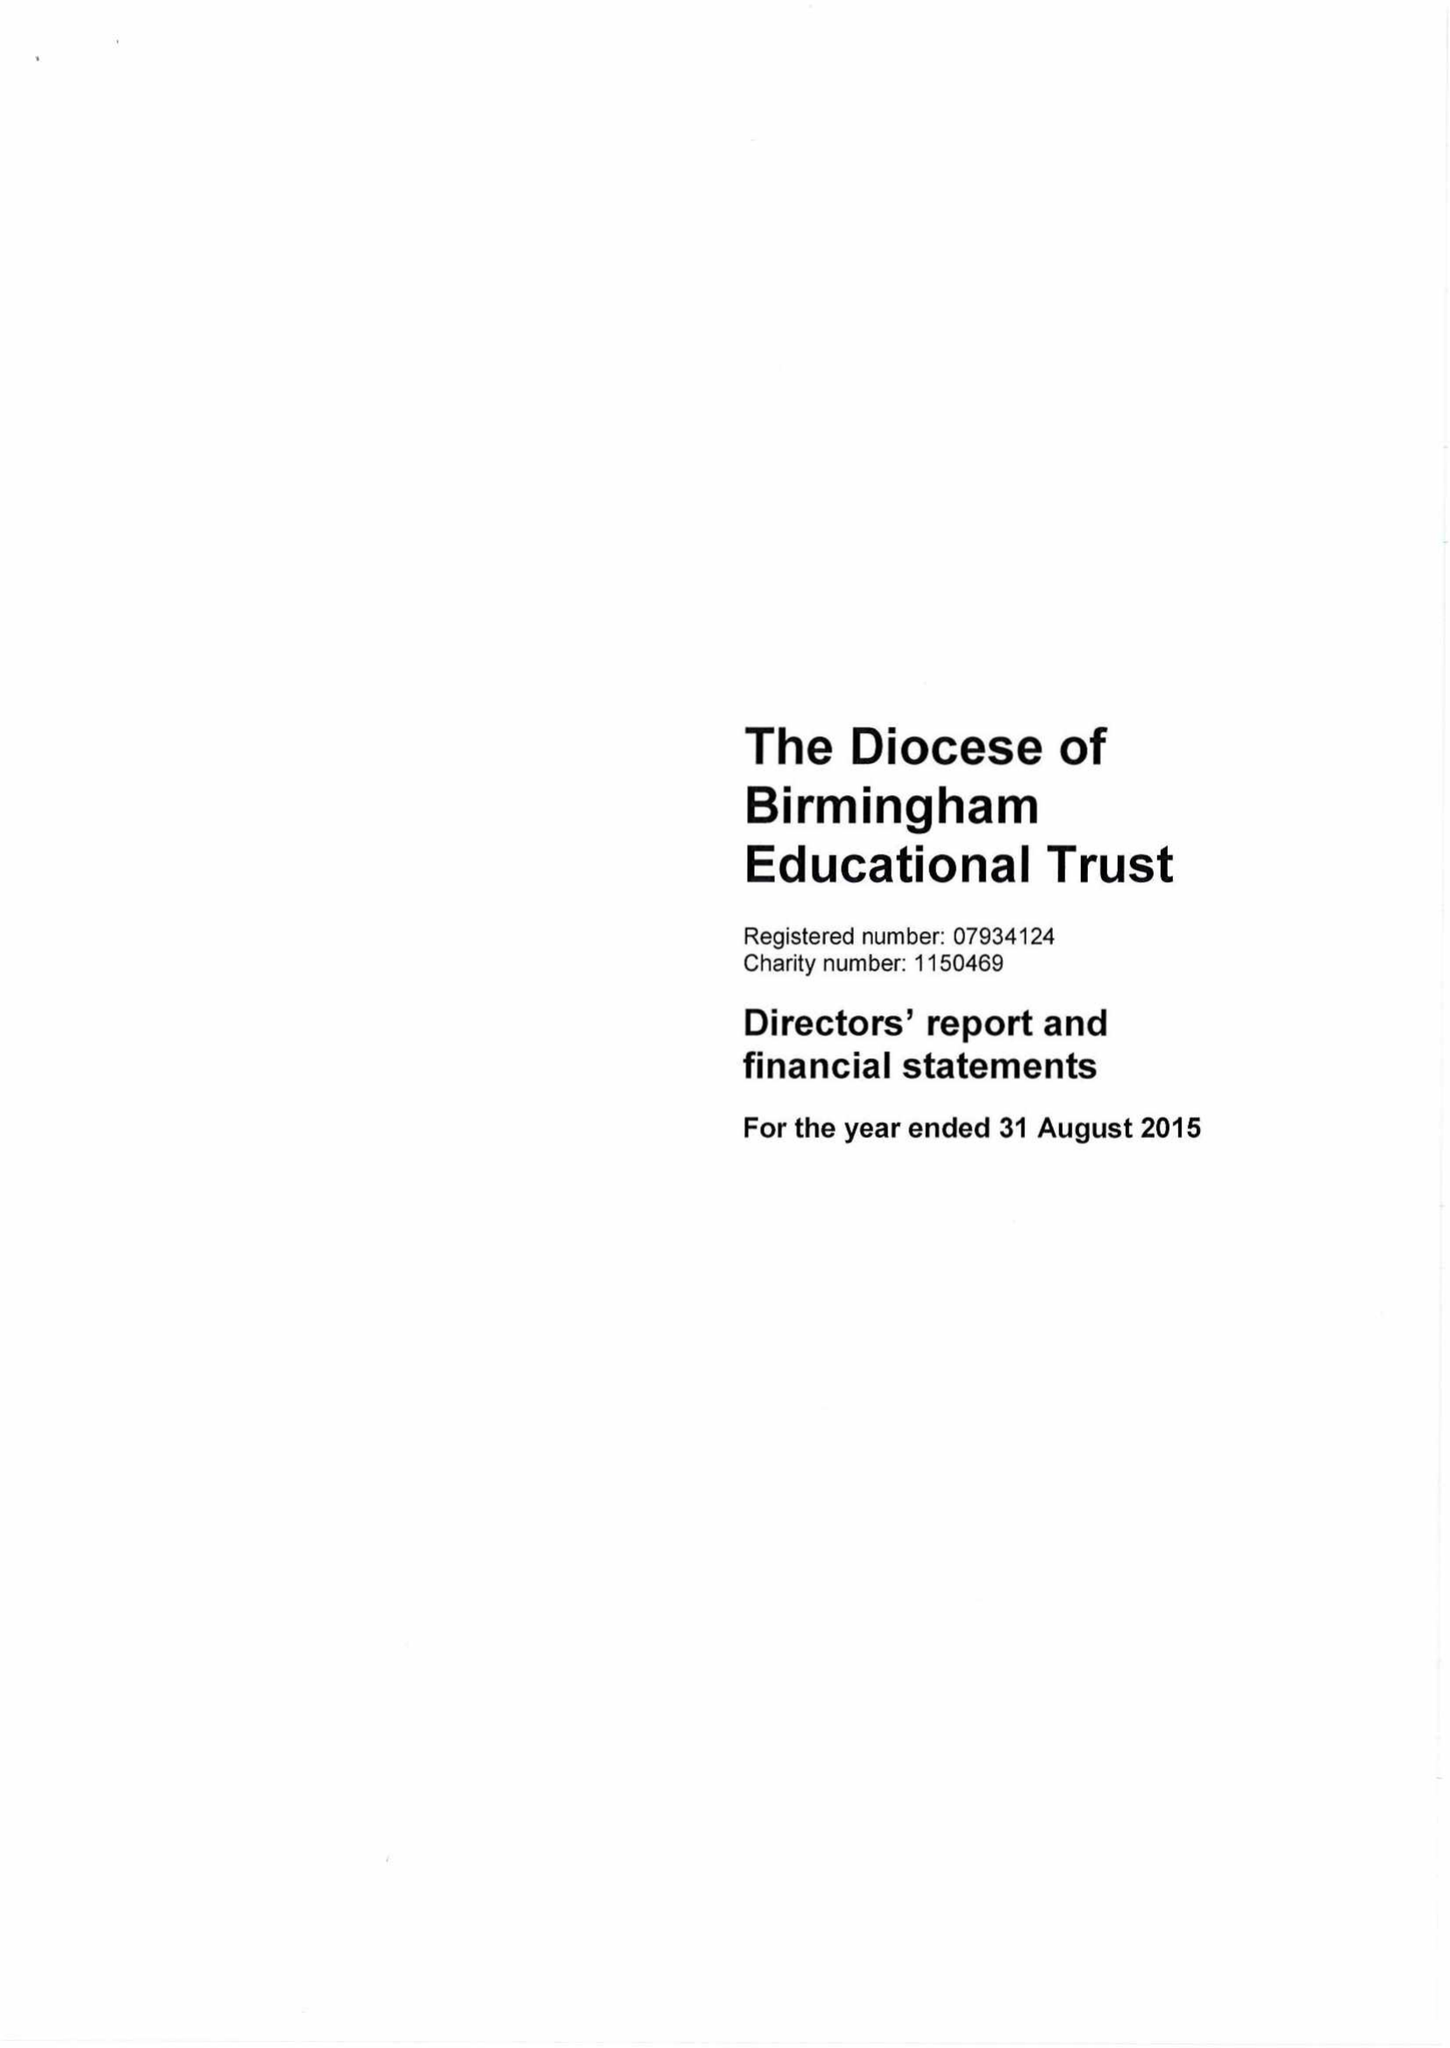What is the value for the address__post_town?
Answer the question using a single word or phrase. BIRMINGHAM 